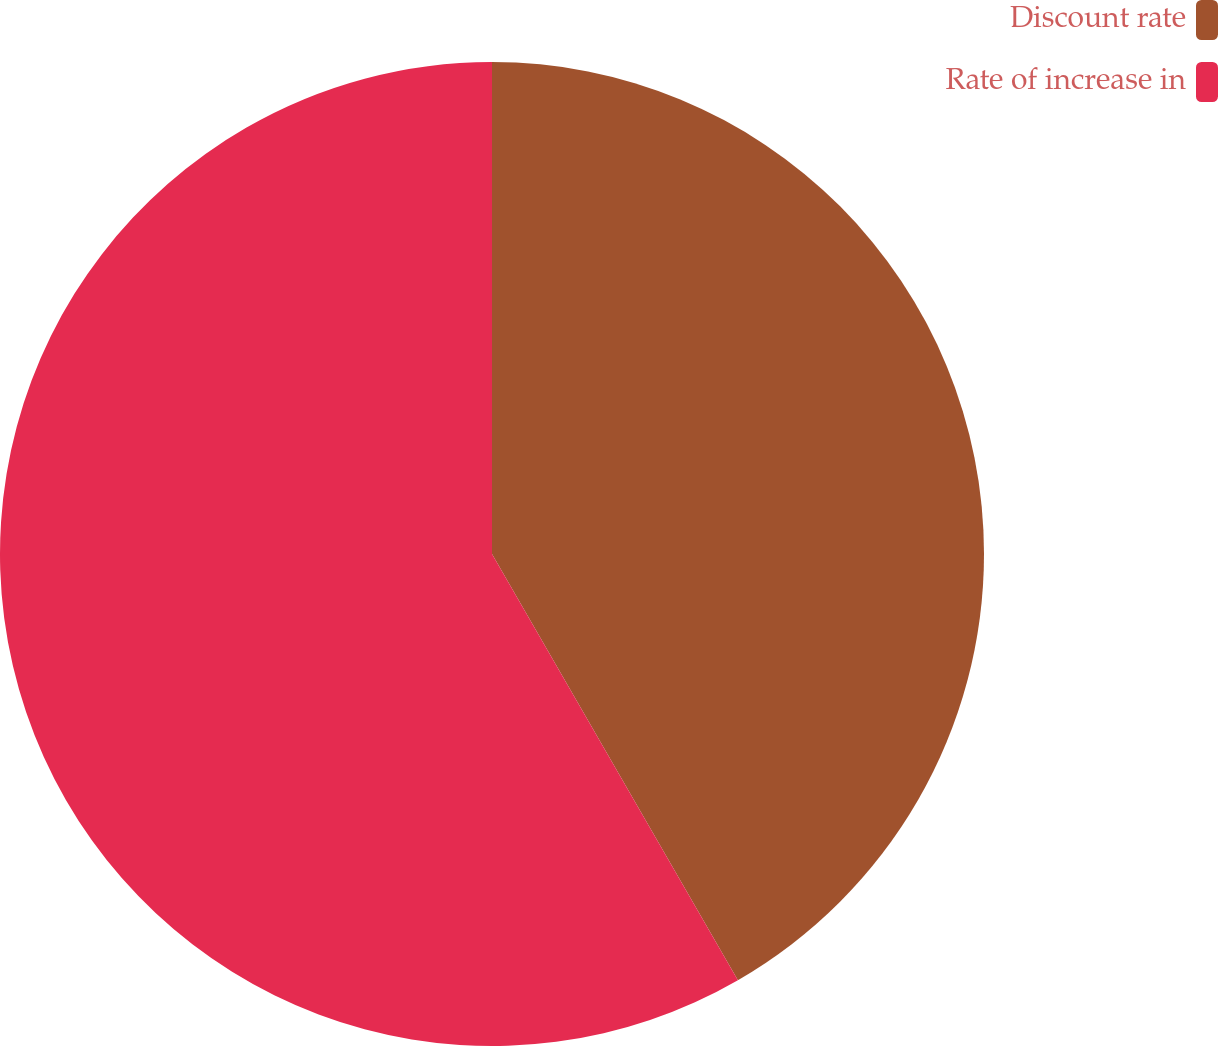Convert chart to OTSL. <chart><loc_0><loc_0><loc_500><loc_500><pie_chart><fcel>Discount rate<fcel>Rate of increase in<nl><fcel>41.67%<fcel>58.33%<nl></chart> 